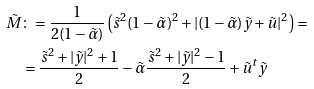<formula> <loc_0><loc_0><loc_500><loc_500>\tilde { M } & \colon = \frac { 1 } { 2 ( 1 - \tilde { \alpha } ) } \left ( \tilde { s } ^ { 2 } ( 1 - \tilde { \alpha } ) ^ { 2 } + | ( 1 - \tilde { \alpha } ) \tilde { y } + \tilde { u } | ^ { 2 } \right ) = \\ & = \frac { \tilde { s } ^ { 2 } + | \tilde { y } | ^ { 2 } + 1 } { 2 } - \tilde { \alpha } \frac { \tilde { s } ^ { 2 } + | \tilde { y } | ^ { 2 } - 1 } { 2 } + \tilde { u } ^ { t } \tilde { y }</formula> 